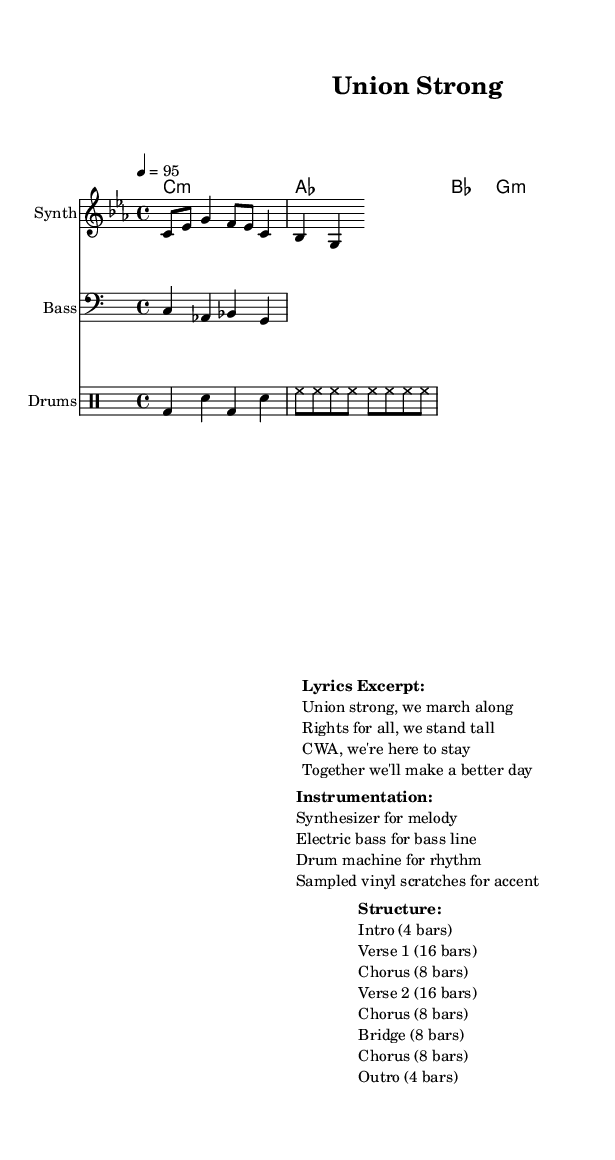What is the key signature of this music? The key signature is C minor, which has three flats (B♭, E♭, A♭). This is derived from the "global" section of the code where it's indicated with "\key c \minor".
Answer: C minor What is the time signature of this score? The time signature is 4/4, as indicated in the "global" section of the code with "\time 4/4". This means there are four beats in each measure and a quarter note gets one beat.
Answer: 4/4 What is the tempo marking provided in the sheet music? The tempo marking is 4 = 95, which means there are 95 beats per minute. This is found in the "global" section of the code after the "\tempo" directive.
Answer: 95 How many bars are there in the chorus section? The chorus section consists of 8 bars, as indicated in the "Structure" section of the markup where it specifically lists the lengths of each part.
Answer: 8 bars What instrument is used for the melody? The melody is performed using a synthesizer, which is specified in the "Instrumentation" section of the markup.
Answer: Synthesizer What type of percussion is used in this piece? The percussion is created with a drum machine, as noted in the "Instrumentation" section of the markup where it describes the rhythm section.
Answer: Drum machine 